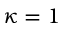<formula> <loc_0><loc_0><loc_500><loc_500>\kappa = 1</formula> 